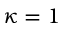<formula> <loc_0><loc_0><loc_500><loc_500>\kappa = 1</formula> 